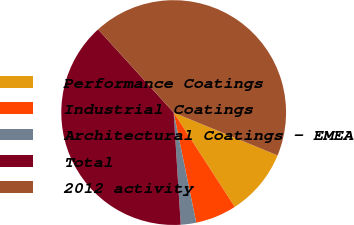Convert chart to OTSL. <chart><loc_0><loc_0><loc_500><loc_500><pie_chart><fcel>Performance Coatings<fcel>Industrial Coatings<fcel>Architectural Coatings - EMEA<fcel>Total<fcel>2012 activity<nl><fcel>9.63%<fcel>5.93%<fcel>2.22%<fcel>39.26%<fcel>42.96%<nl></chart> 